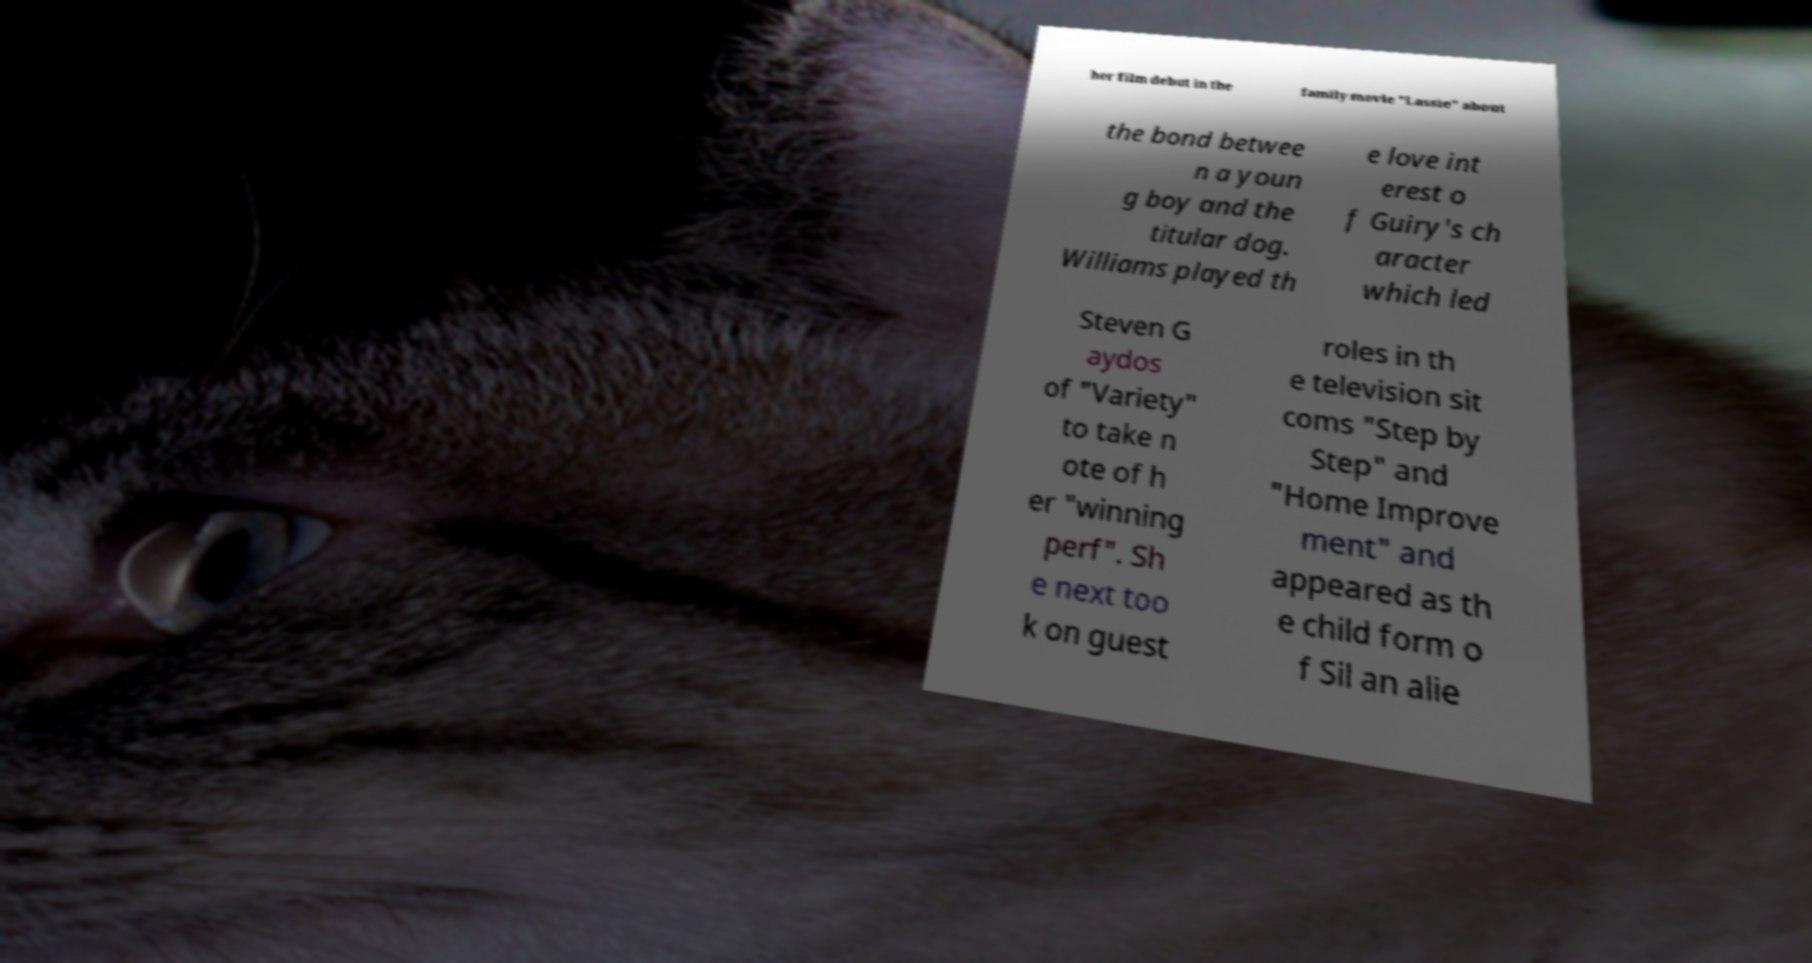Can you read and provide the text displayed in the image?This photo seems to have some interesting text. Can you extract and type it out for me? her film debut in the family movie "Lassie" about the bond betwee n a youn g boy and the titular dog. Williams played th e love int erest o f Guiry's ch aracter which led Steven G aydos of "Variety" to take n ote of h er "winning perf". Sh e next too k on guest roles in th e television sit coms "Step by Step" and "Home Improve ment" and appeared as th e child form o f Sil an alie 